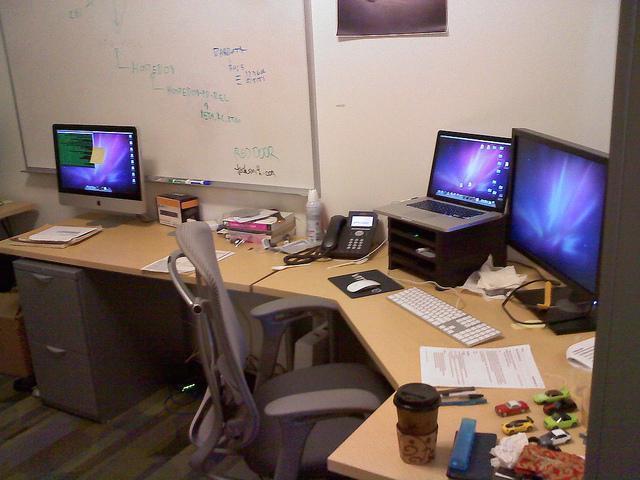How many screens do you see?
Give a very brief answer. 3. How many computer screens are there?
Give a very brief answer. 3. How many drawers are there?
Give a very brief answer. 2. How many monitors are on the desk?
Give a very brief answer. 3. How many laptops are there?
Give a very brief answer. 1. How many tvs can you see?
Give a very brief answer. 2. 